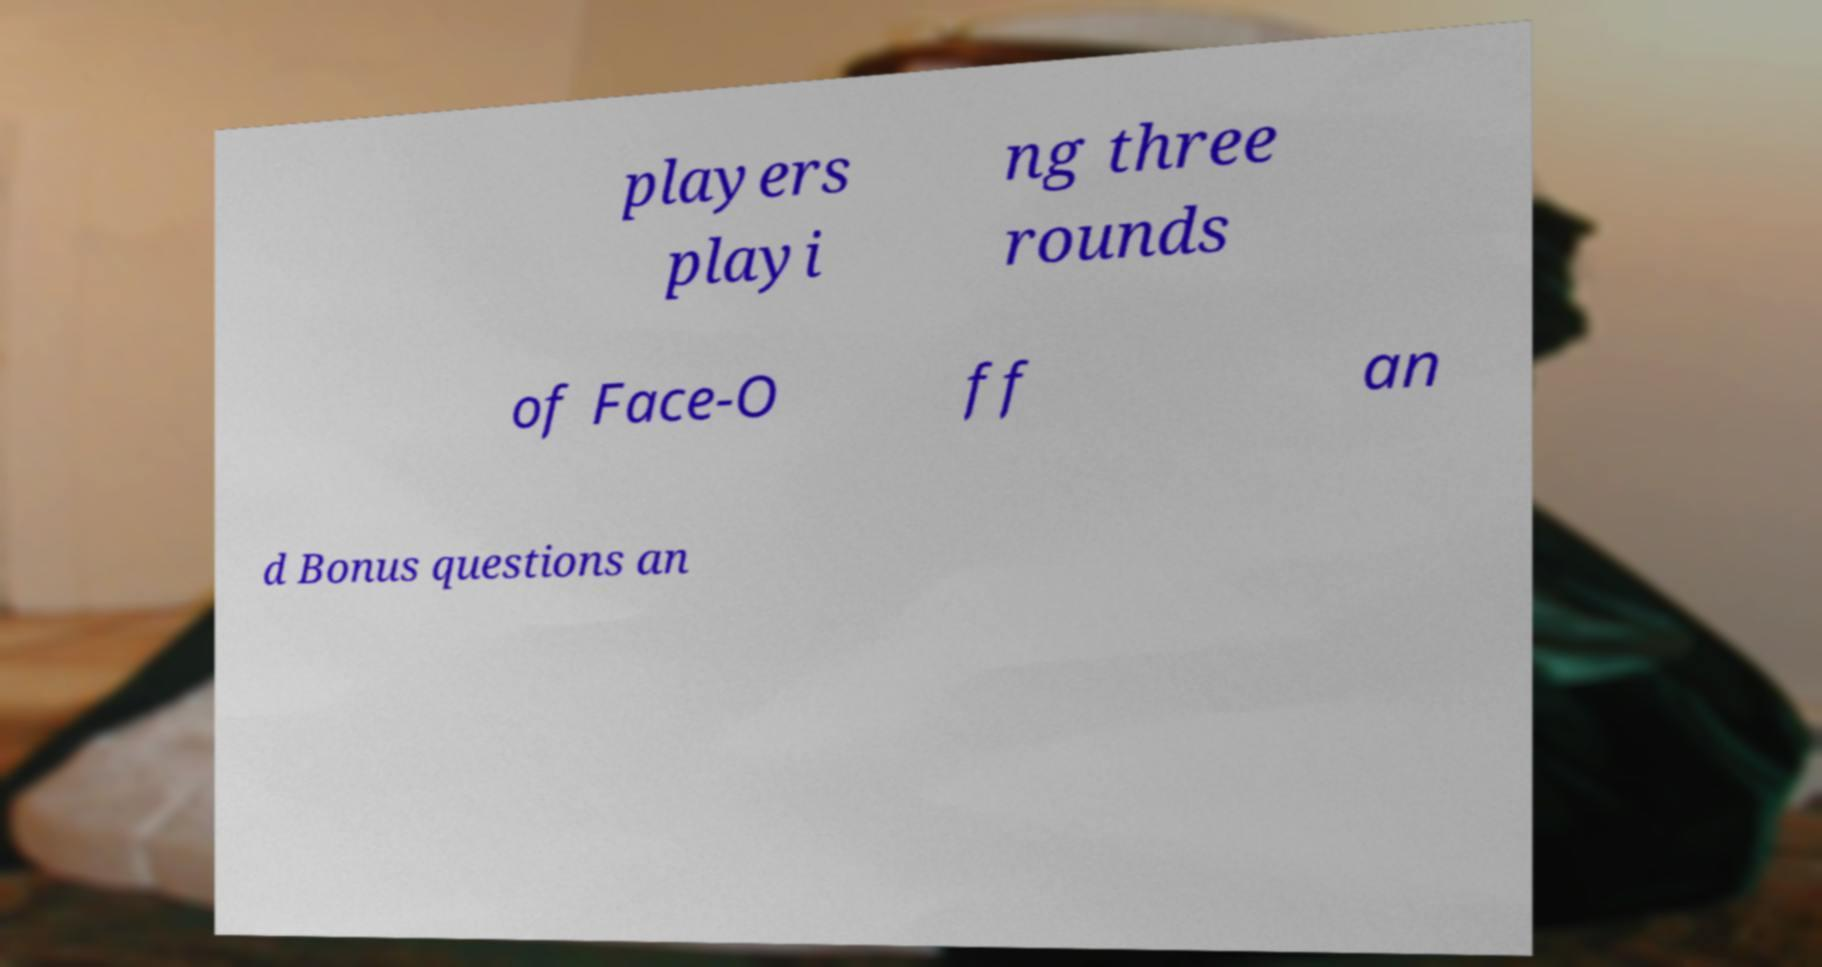Please read and relay the text visible in this image. What does it say? players playi ng three rounds of Face-O ff an d Bonus questions an 